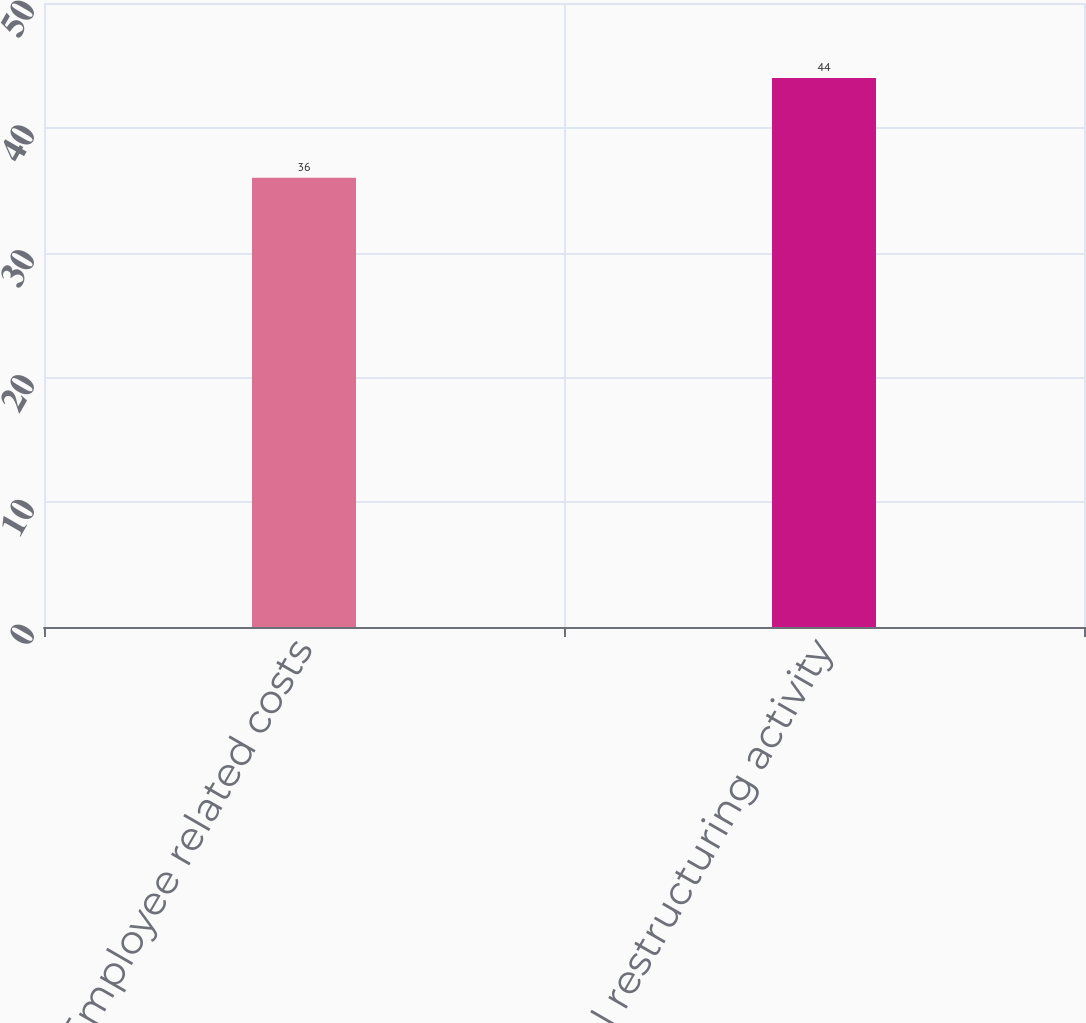<chart> <loc_0><loc_0><loc_500><loc_500><bar_chart><fcel>Employee related costs<fcel>Total restructuring activity<nl><fcel>36<fcel>44<nl></chart> 